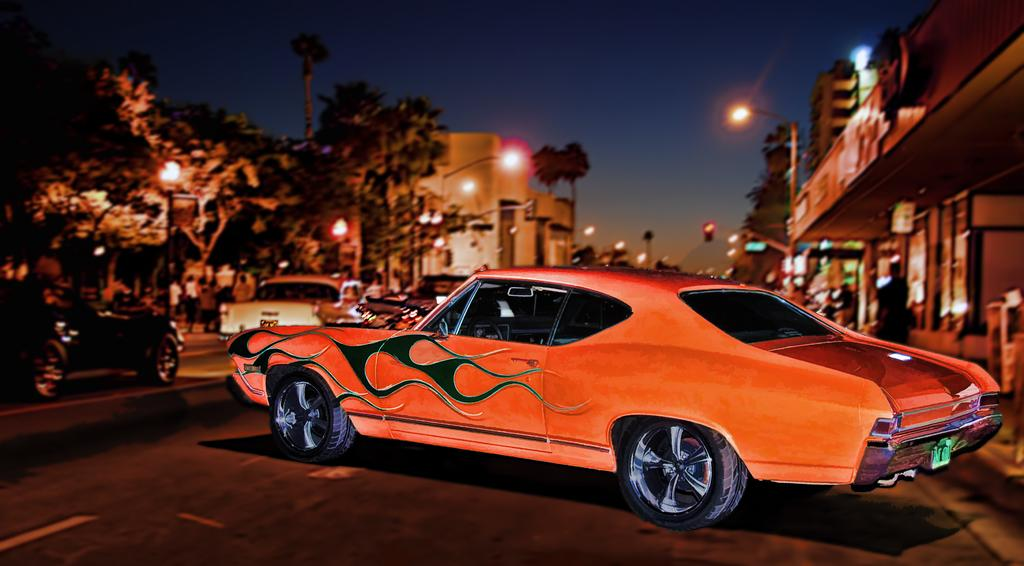What is the color and design of the car in the image? The car in the image is orange with black flames. What can be seen in the background of the image? In the background of the image, there are cars, trees, buildings, and people. What is the color of the sky in the image? The sky is blue in the image, despite being blurred. How many minutes does it take for the plate to be served in the image? There is no plate present in the image, so it is not possible to determine how long it would take to be served. 